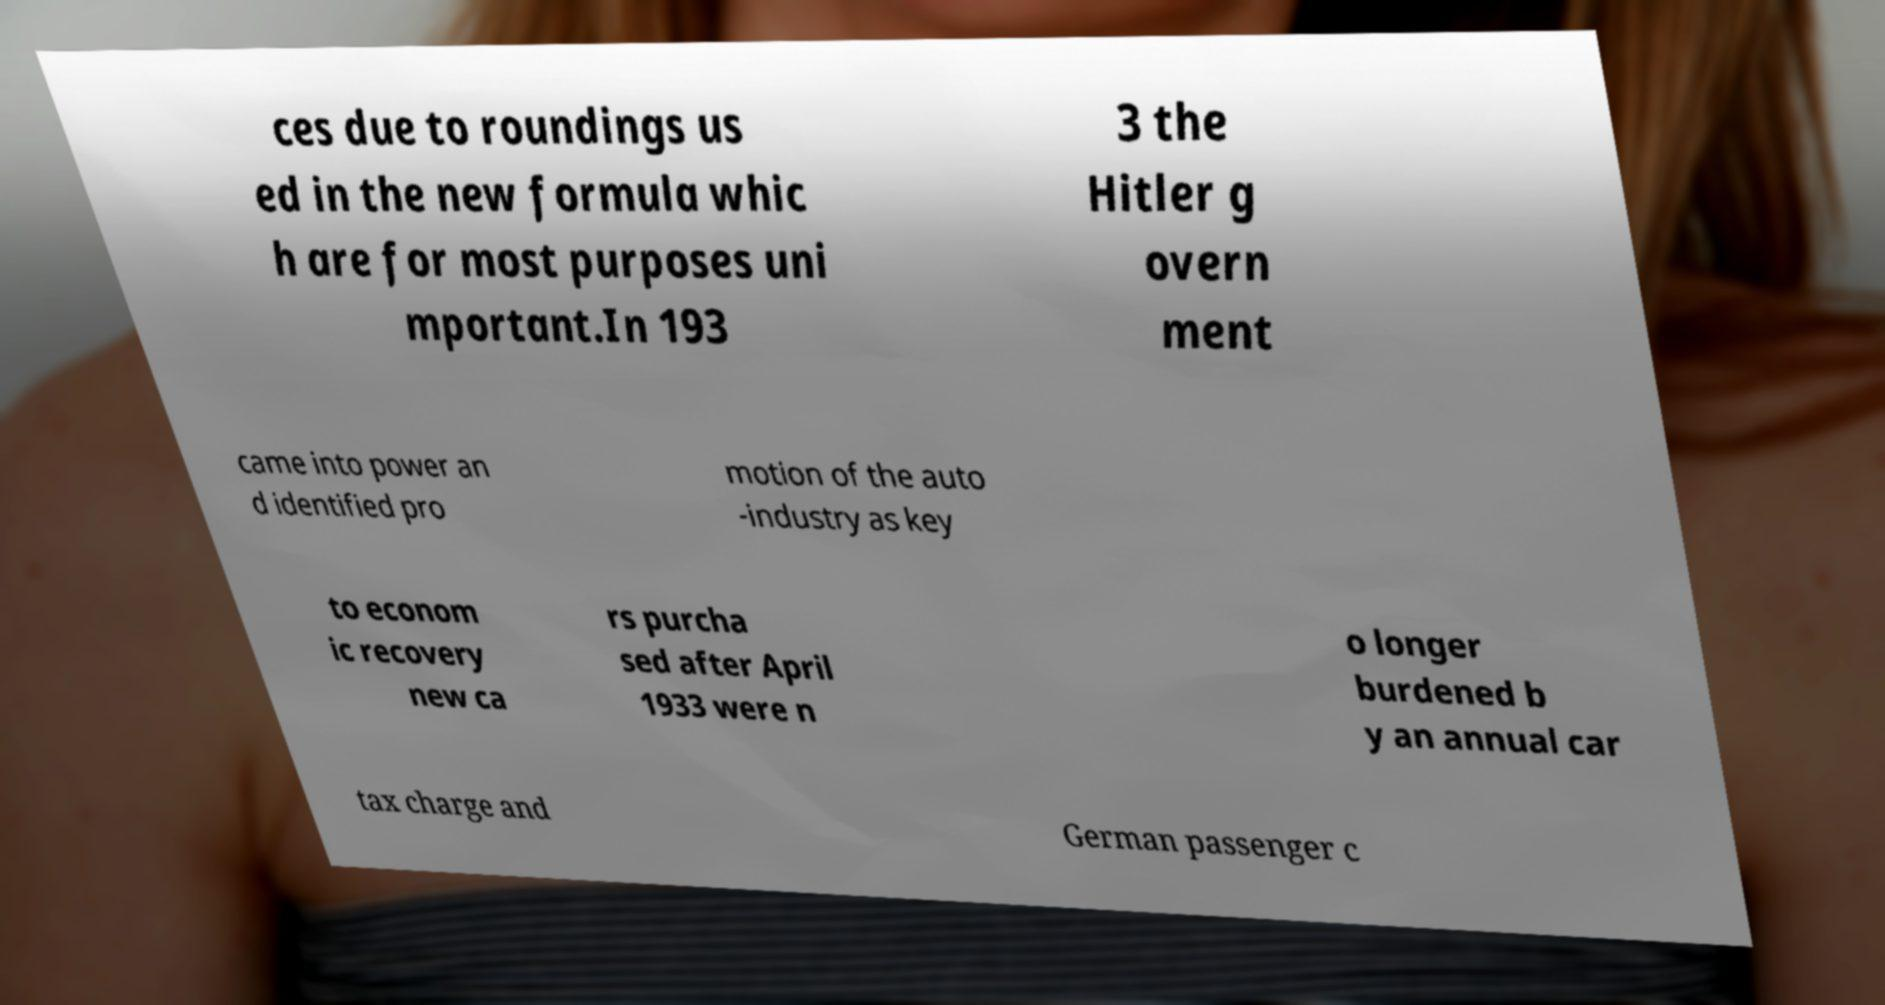I need the written content from this picture converted into text. Can you do that? ces due to roundings us ed in the new formula whic h are for most purposes uni mportant.In 193 3 the Hitler g overn ment came into power an d identified pro motion of the auto -industry as key to econom ic recovery new ca rs purcha sed after April 1933 were n o longer burdened b y an annual car tax charge and German passenger c 